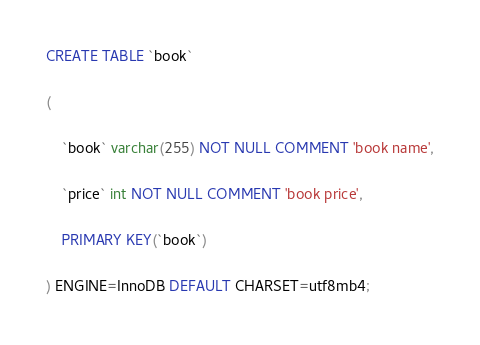<code> <loc_0><loc_0><loc_500><loc_500><_SQL_>CREATE TABLE `book`

(

    `book` varchar(255) NOT NULL COMMENT 'book name',

    `price` int NOT NULL COMMENT 'book price',

    PRIMARY KEY(`book`)

) ENGINE=InnoDB DEFAULT CHARSET=utf8mb4;</code> 